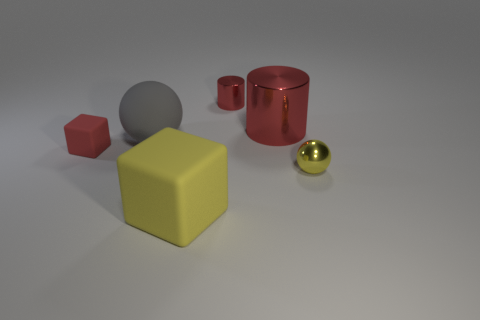Is the number of red cubes on the right side of the yellow ball less than the number of tiny metallic spheres left of the small cube?
Make the answer very short. No. How many tiny red things are the same material as the large yellow thing?
Offer a terse response. 1. There is a red cylinder that is right of the tiny red thing that is on the right side of the big yellow matte block; are there any yellow things to the left of it?
Ensure brevity in your answer.  Yes. How many spheres are large gray things or tiny yellow objects?
Offer a terse response. 2. Is the shape of the tiny red matte thing the same as the big rubber thing to the left of the big yellow object?
Offer a very short reply. No. Are there fewer large red metallic cylinders in front of the small yellow metal object than large matte things?
Your response must be concise. Yes. There is a red matte thing; are there any small rubber blocks behind it?
Keep it short and to the point. No. Are there any small red metal things that have the same shape as the red matte thing?
Your answer should be very brief. No. The yellow rubber thing that is the same size as the gray thing is what shape?
Make the answer very short. Cube. How many things are either large objects behind the big yellow rubber block or tiny yellow matte blocks?
Keep it short and to the point. 2. 